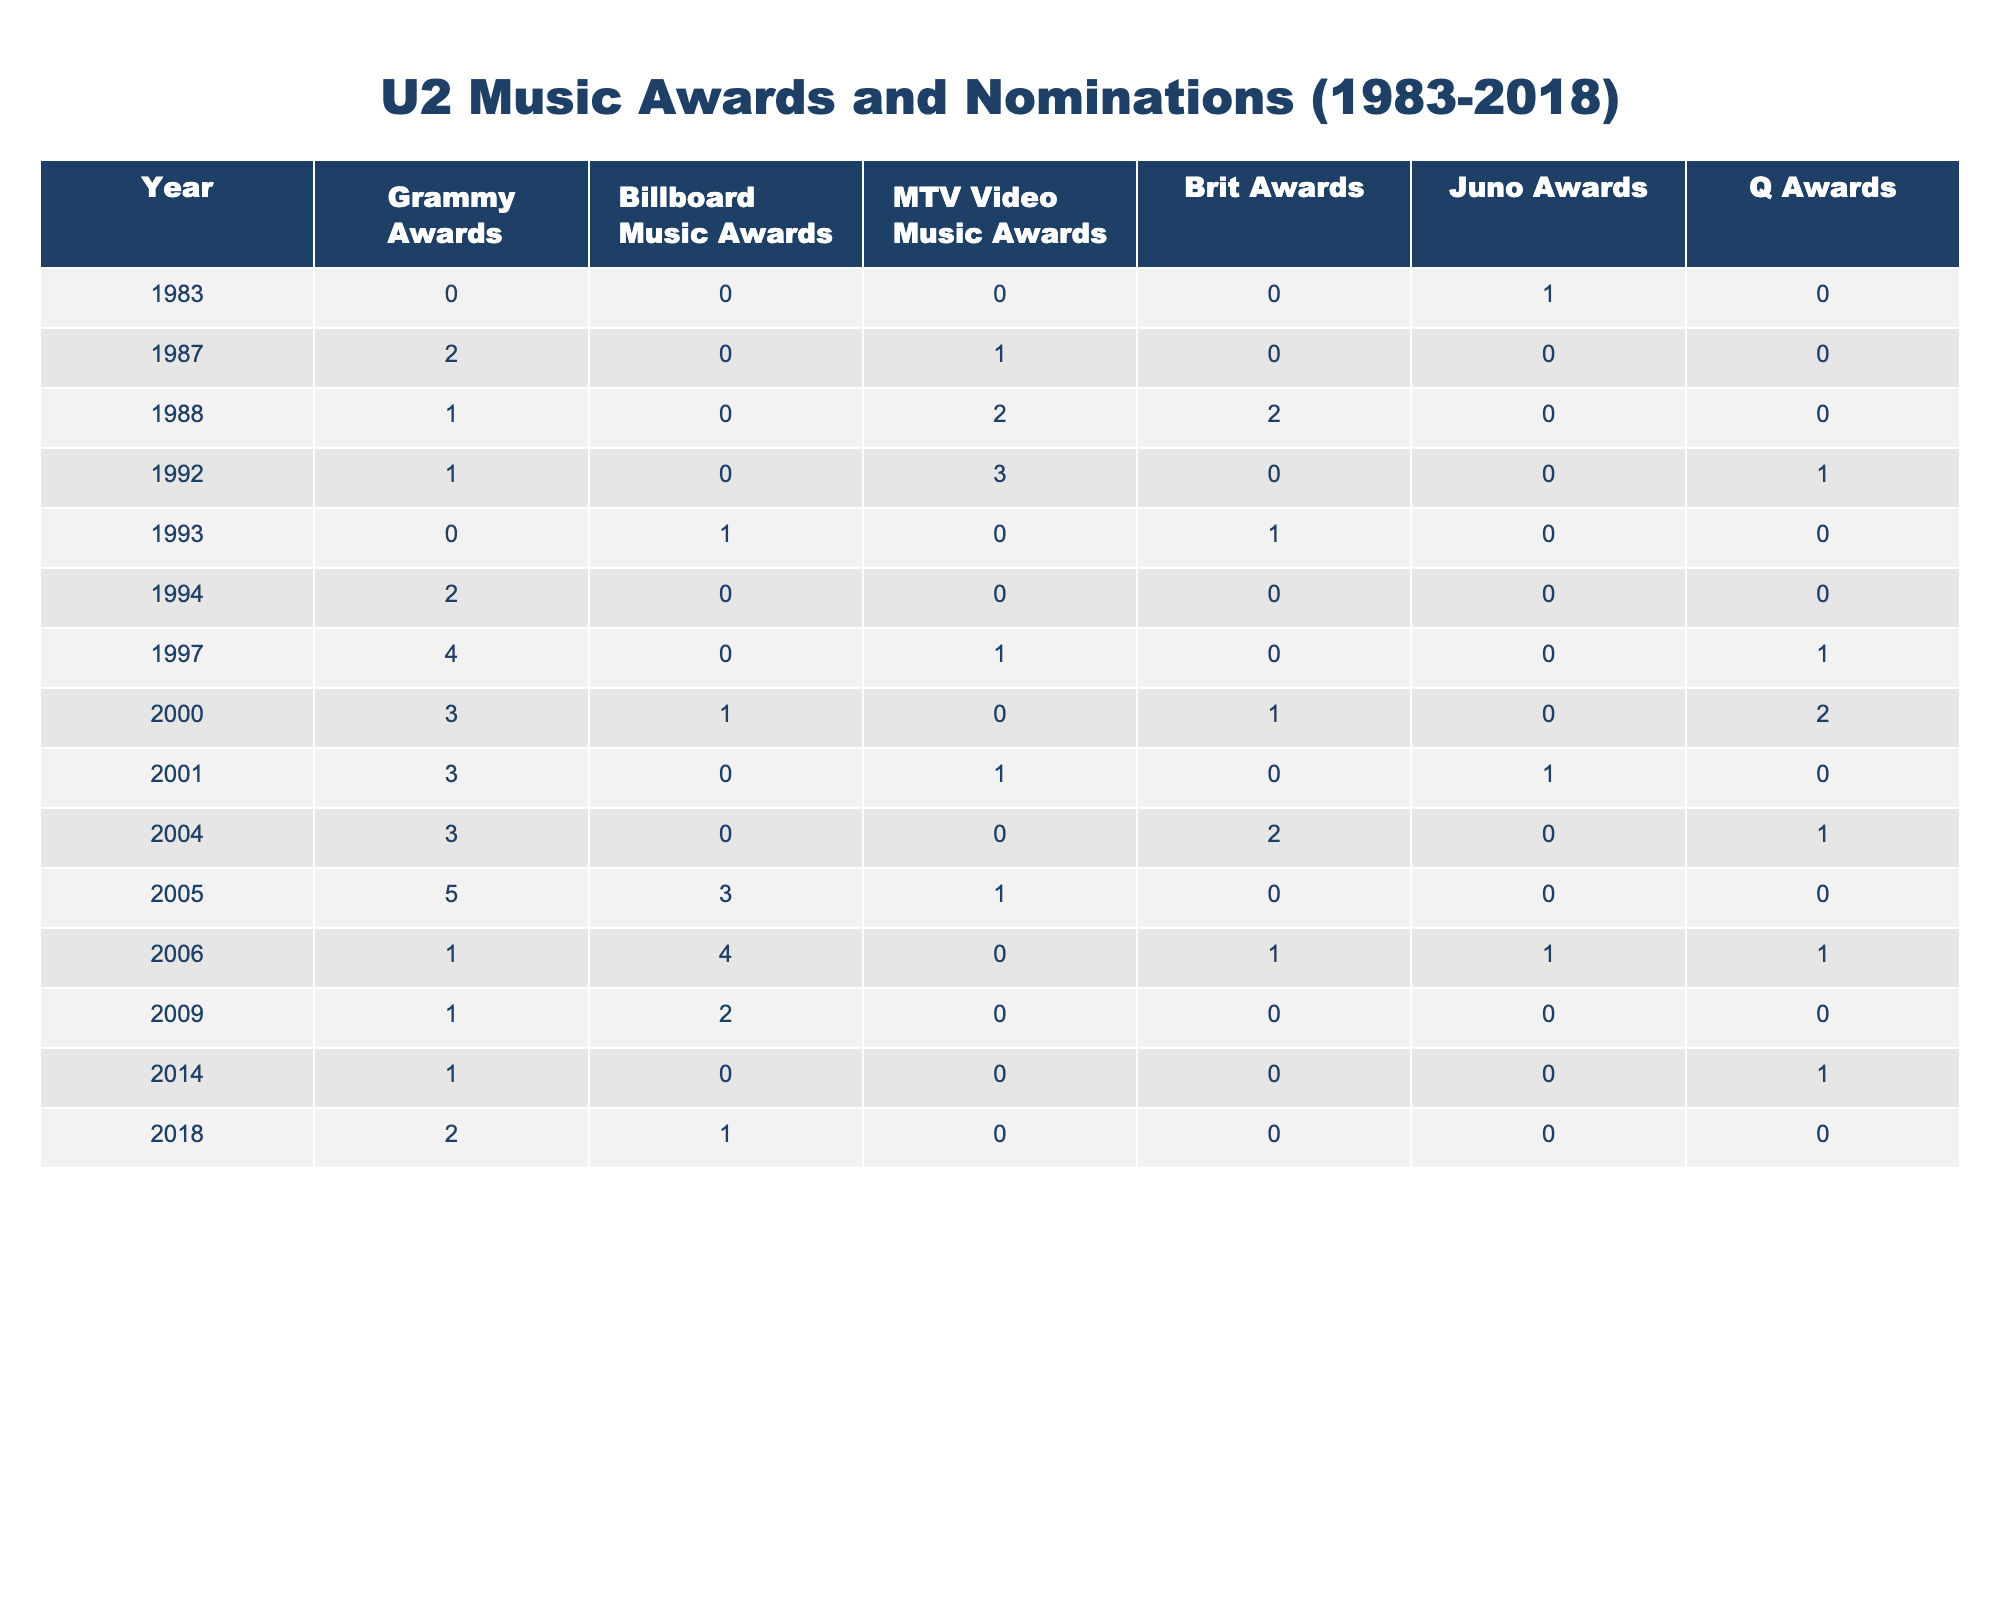What year did U2 receive the most Grammy Awards? By examining the table, the year with the highest number of Grammy Awards for U2 is 2005, when they received 5 awards.
Answer: 2005 How many total MTV Video Music Awards did U2 win from 1983 to 2018? To find the total, we sum the MTV Video Music Awards from each year: 0 + 1 + 2 + 3 + 0 + 1 + 0 + 0 + 0 + 1 + 0 + 0 + 0 + 0 = 8.
Answer: 8 Did U2 win any awards at the Brit Awards in 1993? The table shows that U2 won 1 Brit Award in 1993.
Answer: Yes In which years did U2 not receive any nominations for the Billboard Music Awards? By checking the Billboard Music Awards column, the years without nominations are 1983, 1987, 1988, 1992, 1994, 1997, 2001, 2004, 2014, and 2018. They received 10 total years without nominations.
Answer: 10 What was the average number of Juno Awards U2 won per decade from the data provided? In total, U2 won 4 Juno Awards from the years covered. There are 4 decades (1980s, 1990s, 2000s, and 2010s), so the average is 4 awards / 4 decades = 1 award per decade.
Answer: 1 Which award showed the largest increase in U2's wins from the 1980s to the 2000s? By comparing the Q Awards, U2 had 0 wins in the 1980s and 3 wins in the 2000s—a difference of 3 wins, larger than any other award categories in that time span.
Answer: Q Awards In which single year did U2 have their highest total number of awards (all categories combined)? To determine this, we sum U2's total wins for each year. The year 2005 has the highest total with 5 (Grammy) + 3 (Billboard) + 1 (MTV) + 0 (Brit) + 0 (Juno) + 0 (Q) = 9.
Answer: 2005 Did U2 receive more Grammy Awards than Brit Awards in 1994? According to the table, U2 won 2 Grammy Awards and 0 Brit Awards in 1994, confirming they received more Grammy Awards than Brit Awards.
Answer: Yes What was the trend in U2's Grammy Awards over the years based on this data? Examining the Grammy Awards column shows an initial increase up to 2005, with a few fluctuations but a general decline post-2005.
Answer: Fluctuating decline Which year had the lowest total awards across all categories? By totaling awards for each year and comparing, it's clear that 1983 has the lowest total with 1 award, which was a Juno Award.
Answer: 1983 